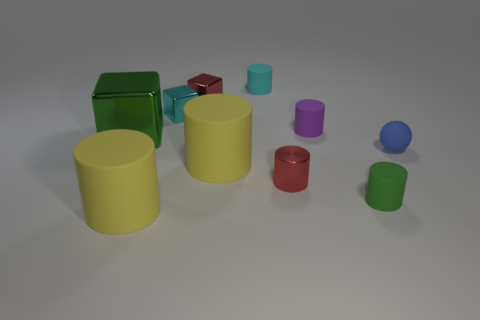Is there a tiny purple thing of the same shape as the tiny cyan metallic object?
Your answer should be compact. No. Are there any other things that have the same shape as the big green shiny thing?
Your response must be concise. Yes. There is a cyan thing left of the tiny rubber object that is on the left side of the red object that is in front of the big metal object; what is it made of?
Provide a succinct answer. Metal. Are there any yellow things of the same size as the rubber ball?
Provide a short and direct response. No. The large rubber cylinder that is left of the tiny cube that is to the right of the tiny cyan shiny cube is what color?
Give a very brief answer. Yellow. What number of red objects are there?
Offer a terse response. 2. Is the number of red things that are behind the blue sphere less than the number of cyan cubes on the right side of the green cylinder?
Make the answer very short. No. What color is the tiny shiny cylinder?
Ensure brevity in your answer.  Red. How many small rubber balls are the same color as the large shiny block?
Provide a short and direct response. 0. There is a small blue matte ball; are there any cyan cylinders in front of it?
Ensure brevity in your answer.  No. 